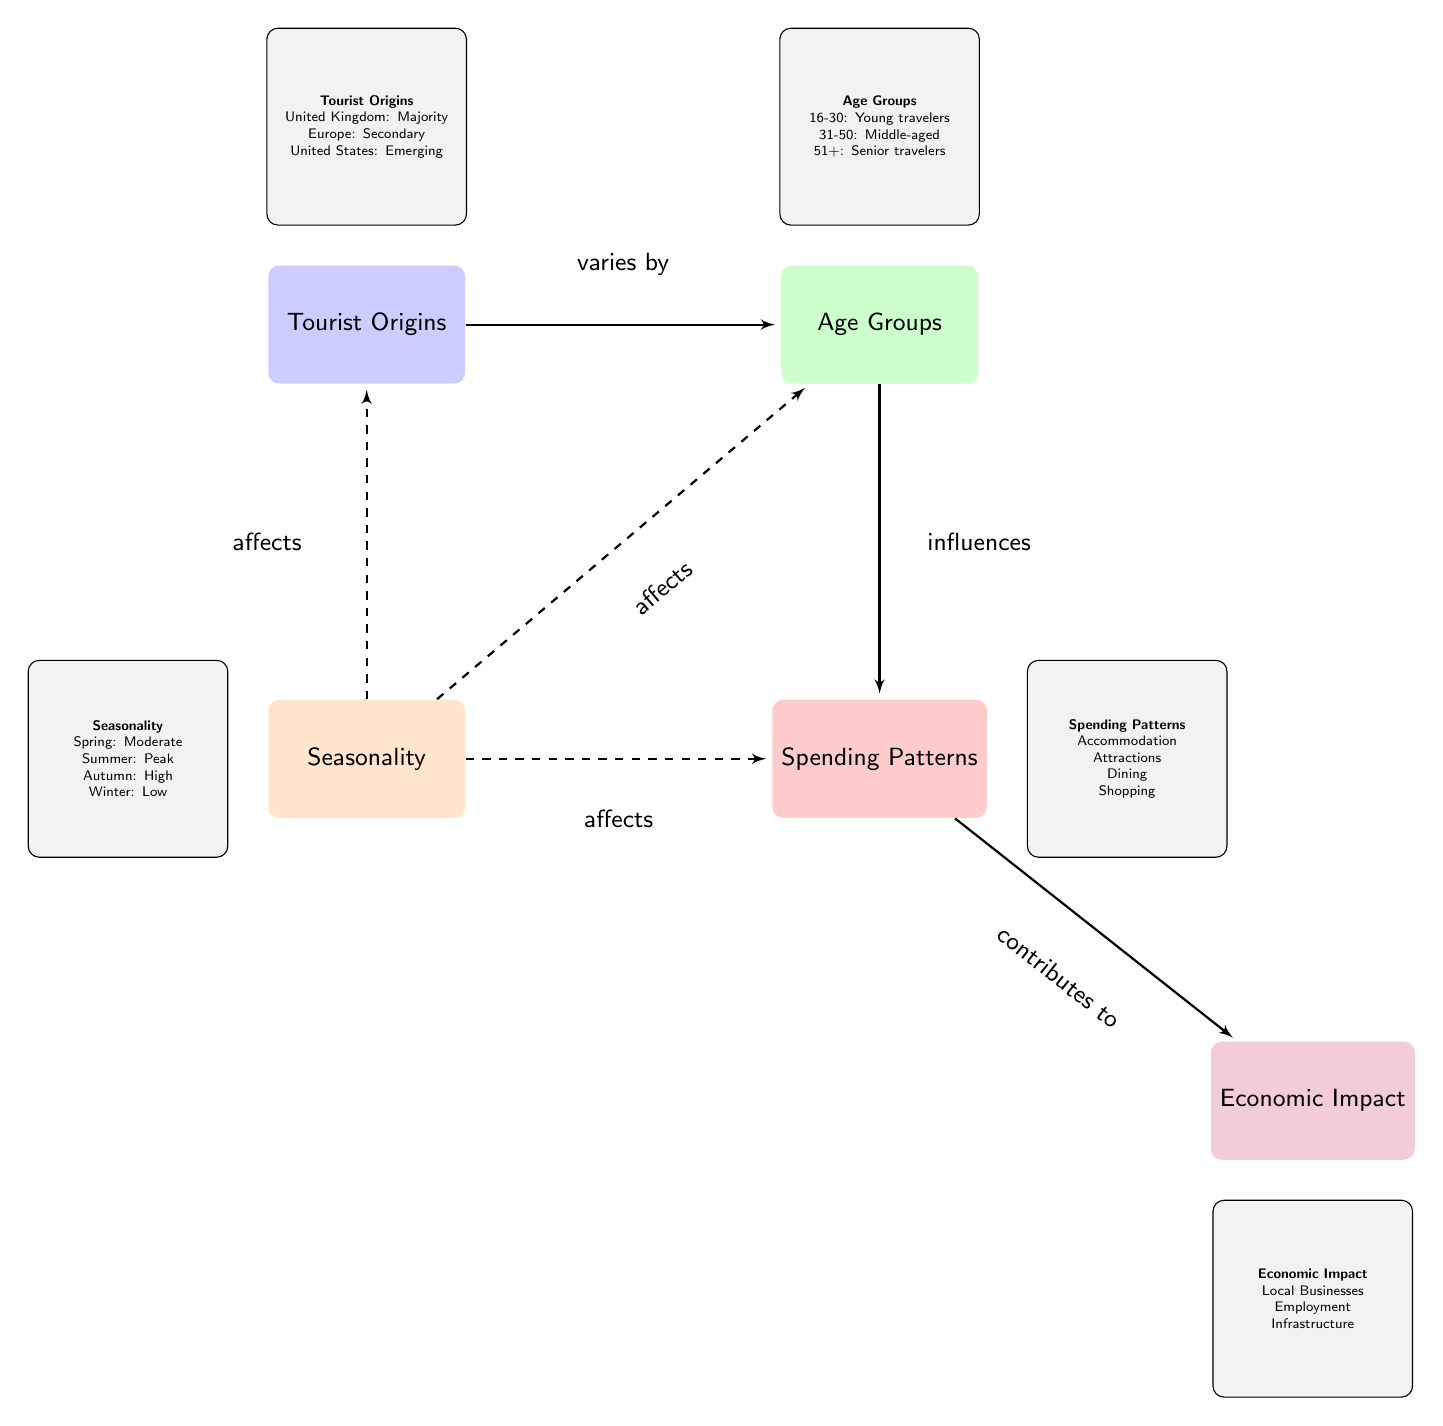What are the three main regions tourist origins come from? The diagram illustrates three primary regions for tourist origins: the United Kingdom, Europe, and the United States. These are clearly listed in the info box next to the "Tourist Origins" node.
Answer: United Kingdom, Europe, United States How many age groups are mentioned in the diagram? The diagram outlines three specific age groups: 16-30, 31-50, and 51+. This can be counted directly from the "Age Groups" node info box.
Answer: 3 What season is noted as having peak tourism? According to the seasonality information provided in the diagram, summer is identified as the peak season for tourism, which is emphasized in the info box under the "Seasonality" node.
Answer: Summer What contributes to the economic impact according to the diagram? The diagram lists three elements that contribute to the economic impact: local businesses, employment, and infrastructure. This information is available in the info box beneath the "Economic Impact" node.
Answer: Local Businesses, Employment, Infrastructure How does seasonality affect spending? The diagram indicates that seasonality directly affects spending patterns, which is represented by a dashed line going from the "Seasonality" node to the "Spending Patterns" node. This relationship suggests that different seasons influence how much tourists spend.
Answer: Affects spending patterns What is the relationship between age groups and spending patterns? The diagram indicates that age groups influence spending habits, illustrated by the solid arrow from the "Age Groups" node to the "Spending Patterns" node. This suggests that the age demographic of tourists can determine their spending behavior during visits.
Answer: Influences spending Which demographic group is described as emerging in tourist origins? Within the "Tourist Origins" info box, the United States is specifically labeled as the emerging demographic group among tourists, indicating a growing interest from that region.
Answer: United States What type of diagram is this? The structure of the diagram, with nodes representing different categories and connecting arrows showing relationships, classifies it as a textbook diagram, primarily used for educational purposes to illustrate concepts.
Answer: Textbook Diagram 